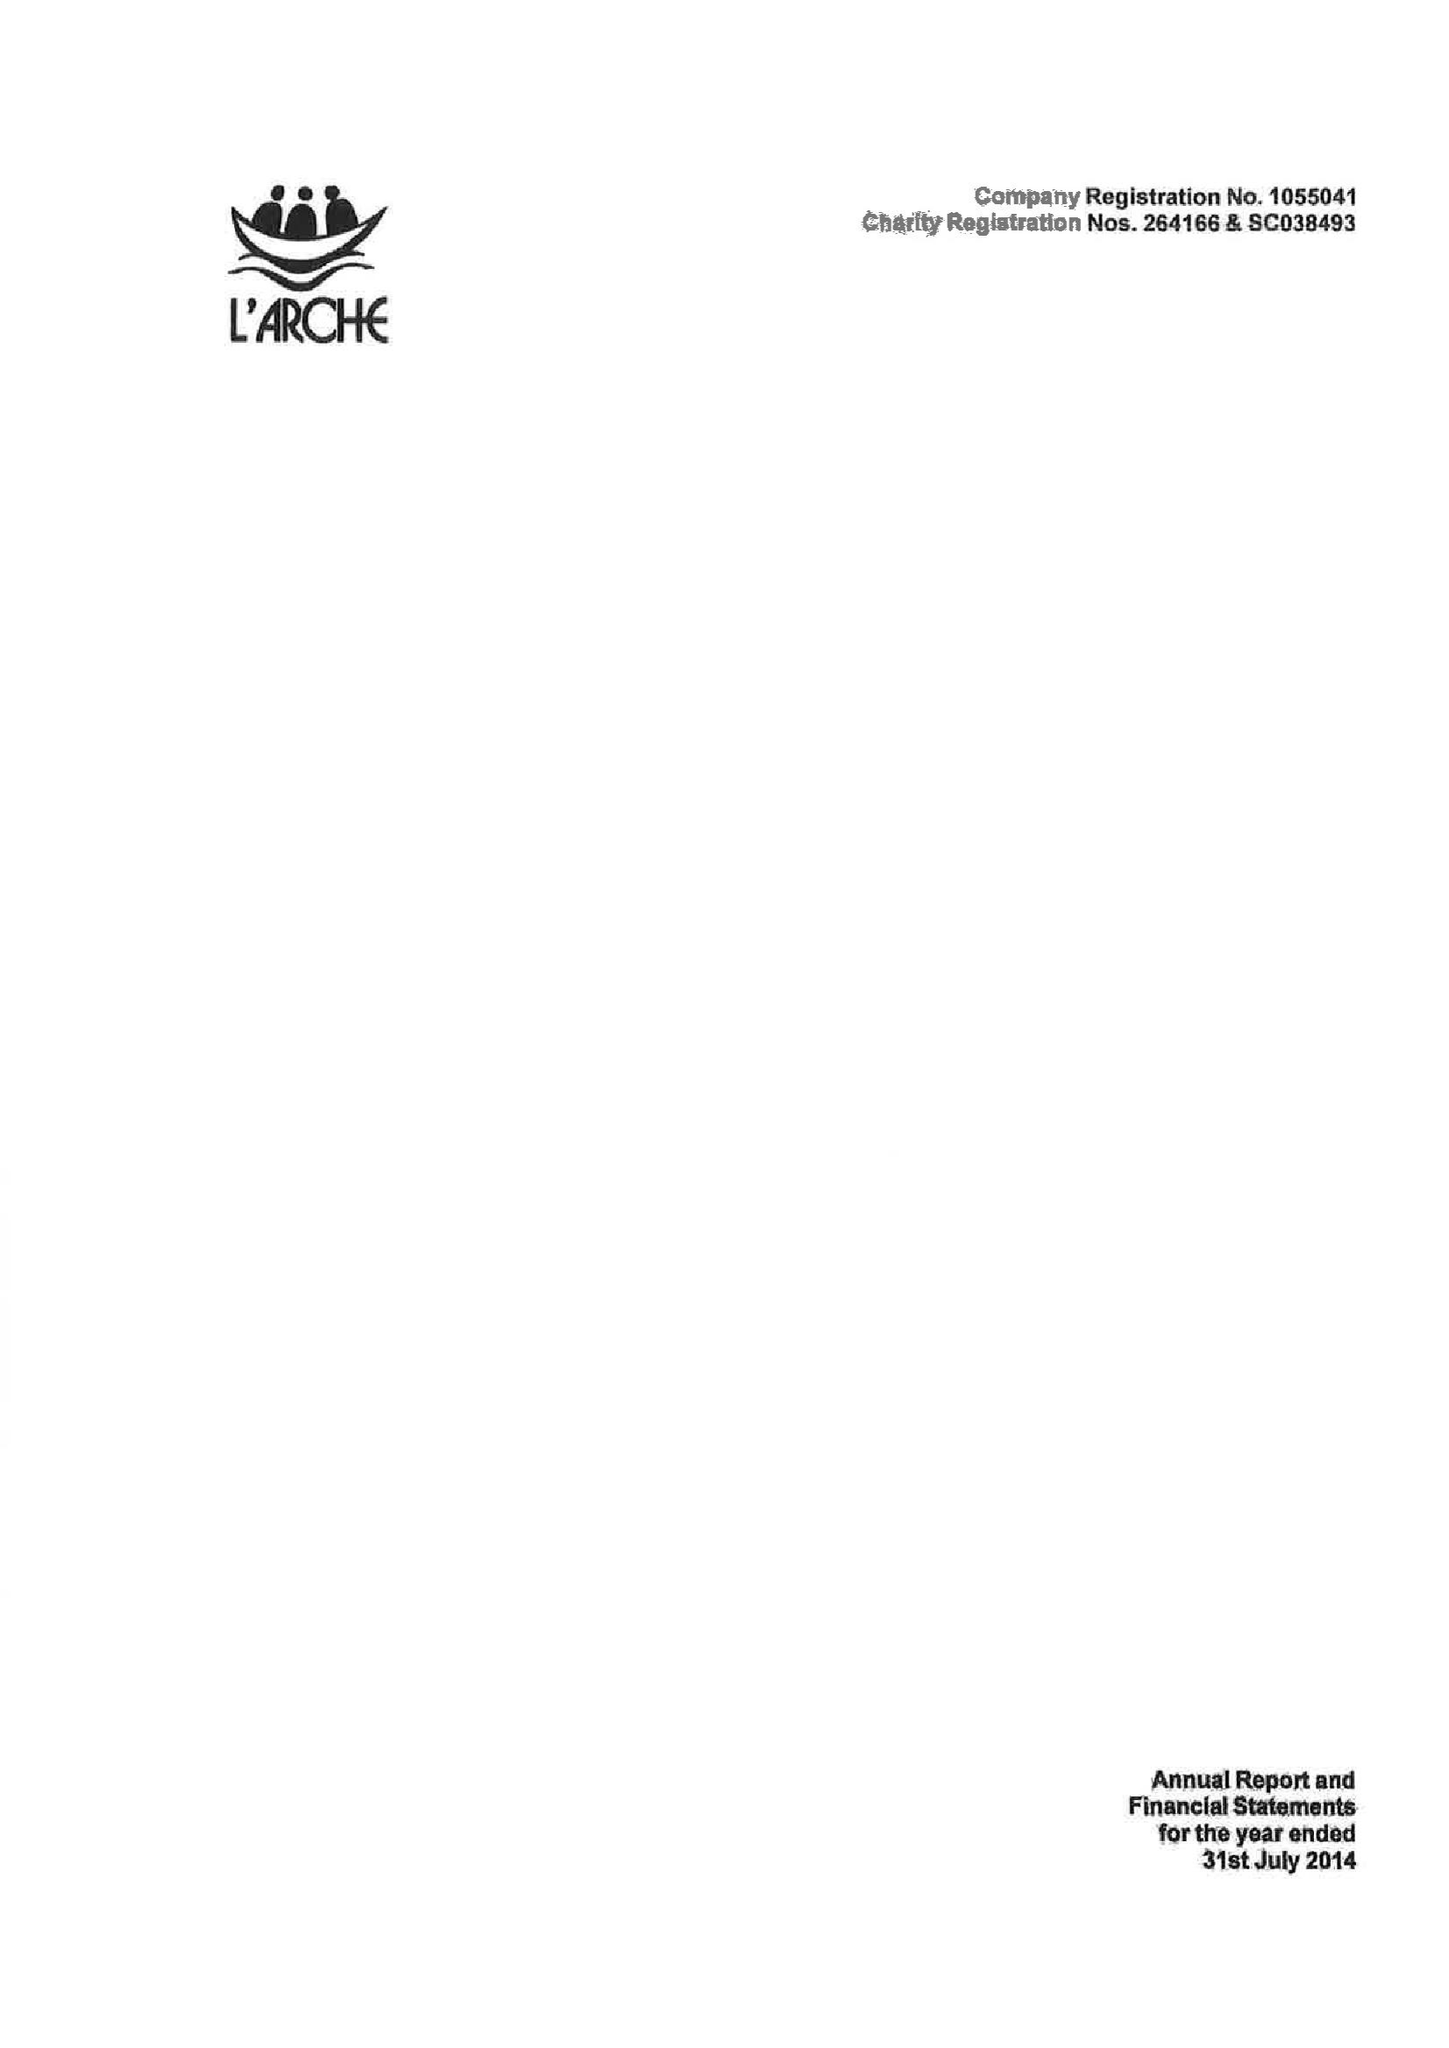What is the value for the address__postcode?
Answer the question using a single word or phrase. BD20 9JT 